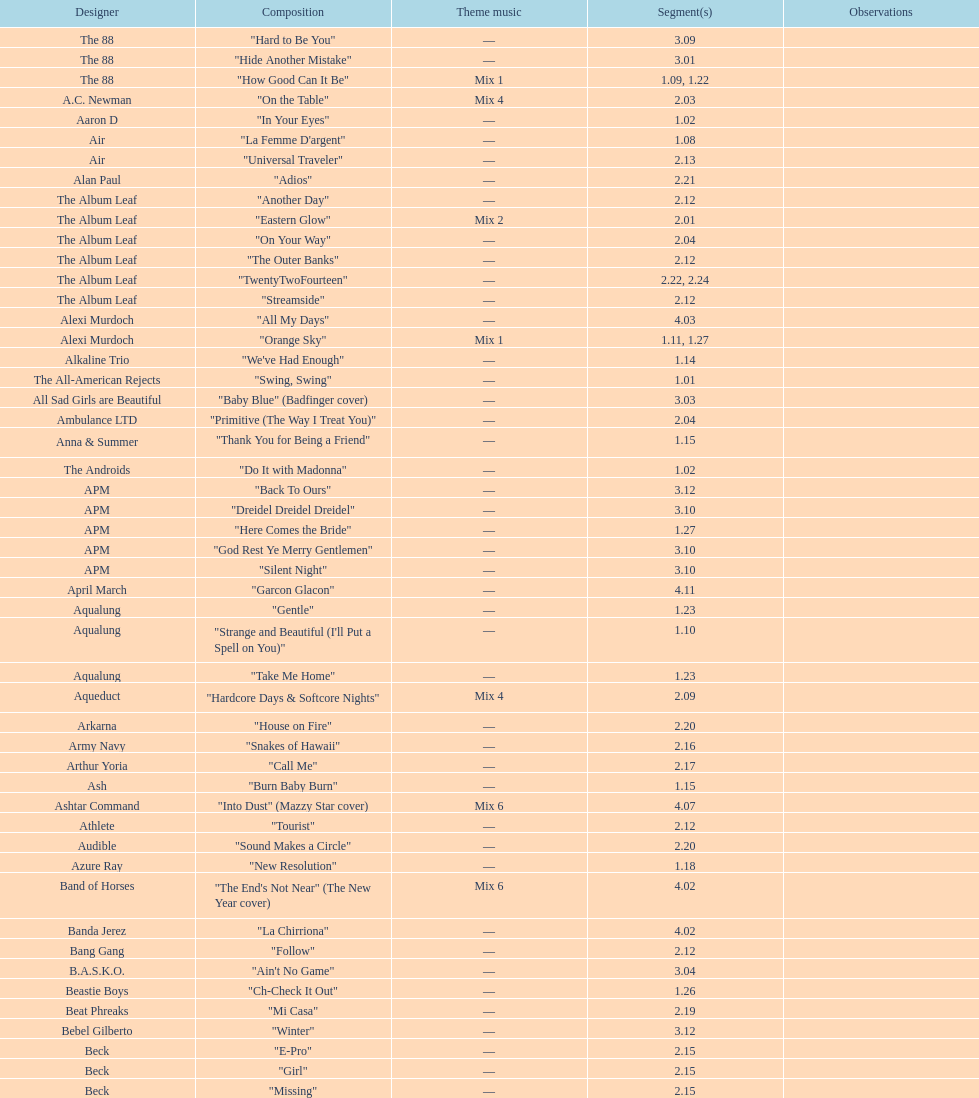How many episodes are below 2.00? 27. 